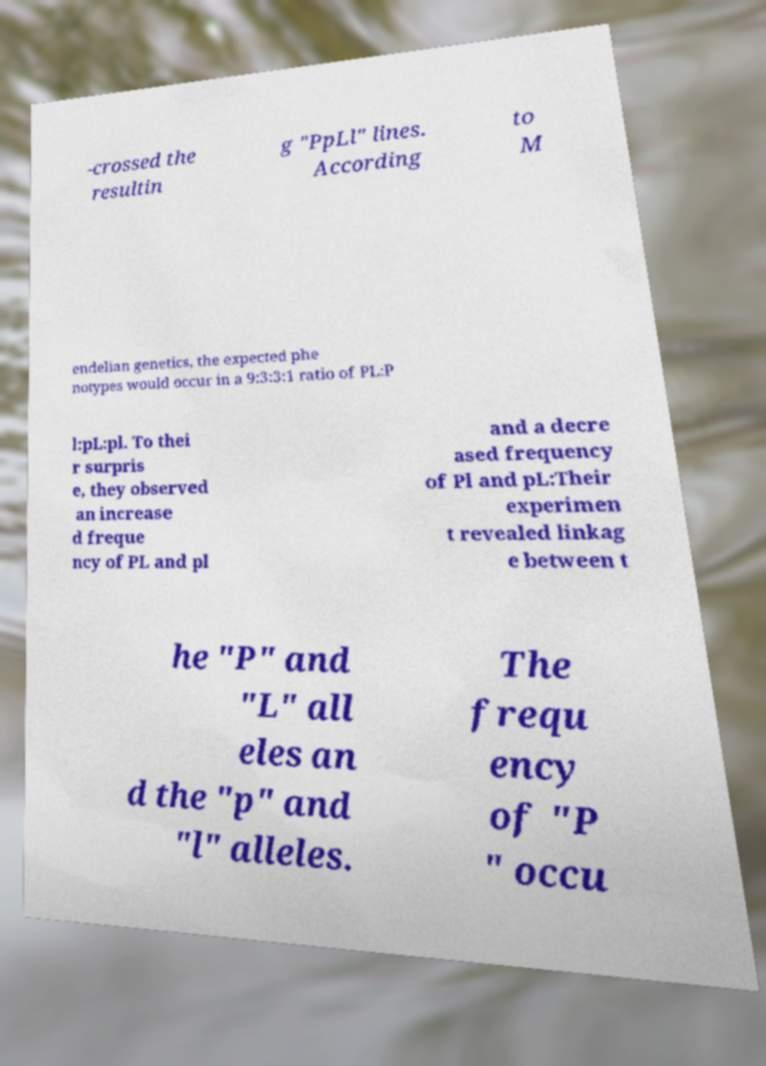What messages or text are displayed in this image? I need them in a readable, typed format. -crossed the resultin g "PpLl" lines. According to M endelian genetics, the expected phe notypes would occur in a 9:3:3:1 ratio of PL:P l:pL:pl. To thei r surpris e, they observed an increase d freque ncy of PL and pl and a decre ased frequency of Pl and pL:Their experimen t revealed linkag e between t he "P" and "L" all eles an d the "p" and "l" alleles. The frequ ency of "P " occu 